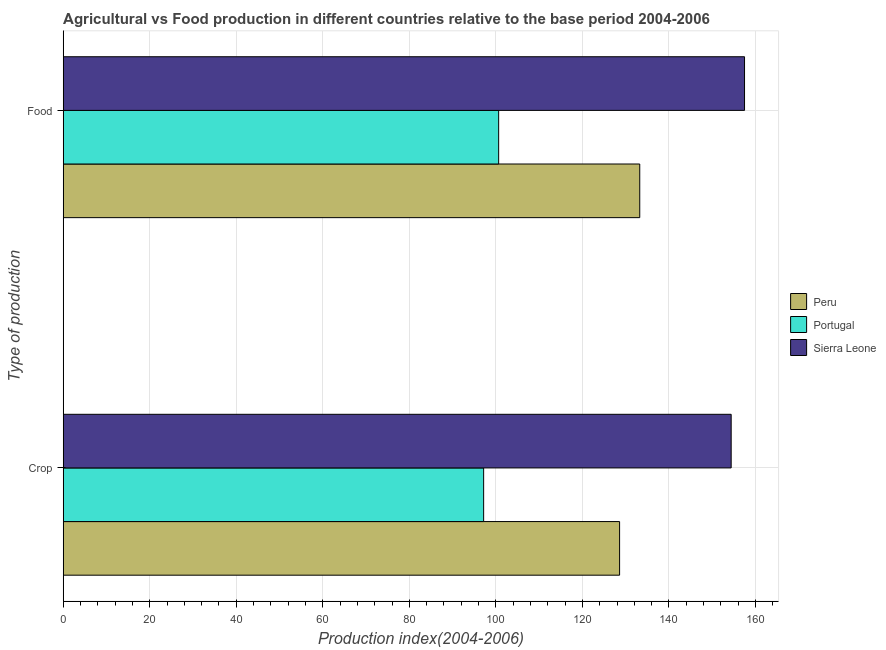How many groups of bars are there?
Make the answer very short. 2. Are the number of bars on each tick of the Y-axis equal?
Your response must be concise. Yes. How many bars are there on the 1st tick from the top?
Give a very brief answer. 3. How many bars are there on the 1st tick from the bottom?
Provide a succinct answer. 3. What is the label of the 2nd group of bars from the top?
Provide a short and direct response. Crop. What is the crop production index in Peru?
Provide a short and direct response. 128.59. Across all countries, what is the maximum crop production index?
Your response must be concise. 154.38. Across all countries, what is the minimum food production index?
Ensure brevity in your answer.  100.64. In which country was the crop production index maximum?
Ensure brevity in your answer.  Sierra Leone. In which country was the crop production index minimum?
Offer a terse response. Portugal. What is the total crop production index in the graph?
Provide a succinct answer. 380.14. What is the difference between the food production index in Sierra Leone and that in Peru?
Offer a terse response. 24.22. What is the difference between the crop production index in Portugal and the food production index in Peru?
Your answer should be compact. -36.08. What is the average food production index per country?
Your response must be concise. 130.45. What is the difference between the crop production index and food production index in Peru?
Make the answer very short. -4.66. In how many countries, is the food production index greater than 16 ?
Your response must be concise. 3. What is the ratio of the food production index in Sierra Leone to that in Peru?
Your answer should be compact. 1.18. Is the crop production index in Portugal less than that in Peru?
Provide a short and direct response. Yes. In how many countries, is the crop production index greater than the average crop production index taken over all countries?
Provide a short and direct response. 2. What does the 1st bar from the top in Crop represents?
Give a very brief answer. Sierra Leone. What does the 3rd bar from the bottom in Food represents?
Your answer should be very brief. Sierra Leone. How many bars are there?
Offer a very short reply. 6. Does the graph contain grids?
Offer a terse response. Yes. How are the legend labels stacked?
Your answer should be very brief. Vertical. What is the title of the graph?
Your answer should be very brief. Agricultural vs Food production in different countries relative to the base period 2004-2006. What is the label or title of the X-axis?
Ensure brevity in your answer.  Production index(2004-2006). What is the label or title of the Y-axis?
Offer a terse response. Type of production. What is the Production index(2004-2006) in Peru in Crop?
Your answer should be compact. 128.59. What is the Production index(2004-2006) of Portugal in Crop?
Your answer should be very brief. 97.17. What is the Production index(2004-2006) of Sierra Leone in Crop?
Keep it short and to the point. 154.38. What is the Production index(2004-2006) in Peru in Food?
Your answer should be compact. 133.25. What is the Production index(2004-2006) in Portugal in Food?
Keep it short and to the point. 100.64. What is the Production index(2004-2006) in Sierra Leone in Food?
Give a very brief answer. 157.47. Across all Type of production, what is the maximum Production index(2004-2006) in Peru?
Provide a short and direct response. 133.25. Across all Type of production, what is the maximum Production index(2004-2006) in Portugal?
Provide a short and direct response. 100.64. Across all Type of production, what is the maximum Production index(2004-2006) of Sierra Leone?
Offer a very short reply. 157.47. Across all Type of production, what is the minimum Production index(2004-2006) of Peru?
Offer a terse response. 128.59. Across all Type of production, what is the minimum Production index(2004-2006) of Portugal?
Provide a short and direct response. 97.17. Across all Type of production, what is the minimum Production index(2004-2006) in Sierra Leone?
Give a very brief answer. 154.38. What is the total Production index(2004-2006) of Peru in the graph?
Your answer should be very brief. 261.84. What is the total Production index(2004-2006) of Portugal in the graph?
Offer a terse response. 197.81. What is the total Production index(2004-2006) of Sierra Leone in the graph?
Ensure brevity in your answer.  311.85. What is the difference between the Production index(2004-2006) of Peru in Crop and that in Food?
Offer a terse response. -4.66. What is the difference between the Production index(2004-2006) of Portugal in Crop and that in Food?
Your response must be concise. -3.47. What is the difference between the Production index(2004-2006) of Sierra Leone in Crop and that in Food?
Your response must be concise. -3.09. What is the difference between the Production index(2004-2006) in Peru in Crop and the Production index(2004-2006) in Portugal in Food?
Provide a short and direct response. 27.95. What is the difference between the Production index(2004-2006) in Peru in Crop and the Production index(2004-2006) in Sierra Leone in Food?
Keep it short and to the point. -28.88. What is the difference between the Production index(2004-2006) in Portugal in Crop and the Production index(2004-2006) in Sierra Leone in Food?
Your answer should be very brief. -60.3. What is the average Production index(2004-2006) in Peru per Type of production?
Give a very brief answer. 130.92. What is the average Production index(2004-2006) of Portugal per Type of production?
Offer a terse response. 98.91. What is the average Production index(2004-2006) in Sierra Leone per Type of production?
Give a very brief answer. 155.93. What is the difference between the Production index(2004-2006) in Peru and Production index(2004-2006) in Portugal in Crop?
Ensure brevity in your answer.  31.42. What is the difference between the Production index(2004-2006) of Peru and Production index(2004-2006) of Sierra Leone in Crop?
Give a very brief answer. -25.79. What is the difference between the Production index(2004-2006) of Portugal and Production index(2004-2006) of Sierra Leone in Crop?
Keep it short and to the point. -57.21. What is the difference between the Production index(2004-2006) of Peru and Production index(2004-2006) of Portugal in Food?
Offer a very short reply. 32.61. What is the difference between the Production index(2004-2006) in Peru and Production index(2004-2006) in Sierra Leone in Food?
Keep it short and to the point. -24.22. What is the difference between the Production index(2004-2006) of Portugal and Production index(2004-2006) of Sierra Leone in Food?
Provide a succinct answer. -56.83. What is the ratio of the Production index(2004-2006) in Portugal in Crop to that in Food?
Offer a terse response. 0.97. What is the ratio of the Production index(2004-2006) in Sierra Leone in Crop to that in Food?
Your answer should be very brief. 0.98. What is the difference between the highest and the second highest Production index(2004-2006) of Peru?
Your response must be concise. 4.66. What is the difference between the highest and the second highest Production index(2004-2006) of Portugal?
Provide a succinct answer. 3.47. What is the difference between the highest and the second highest Production index(2004-2006) in Sierra Leone?
Offer a terse response. 3.09. What is the difference between the highest and the lowest Production index(2004-2006) of Peru?
Give a very brief answer. 4.66. What is the difference between the highest and the lowest Production index(2004-2006) of Portugal?
Your response must be concise. 3.47. What is the difference between the highest and the lowest Production index(2004-2006) in Sierra Leone?
Ensure brevity in your answer.  3.09. 